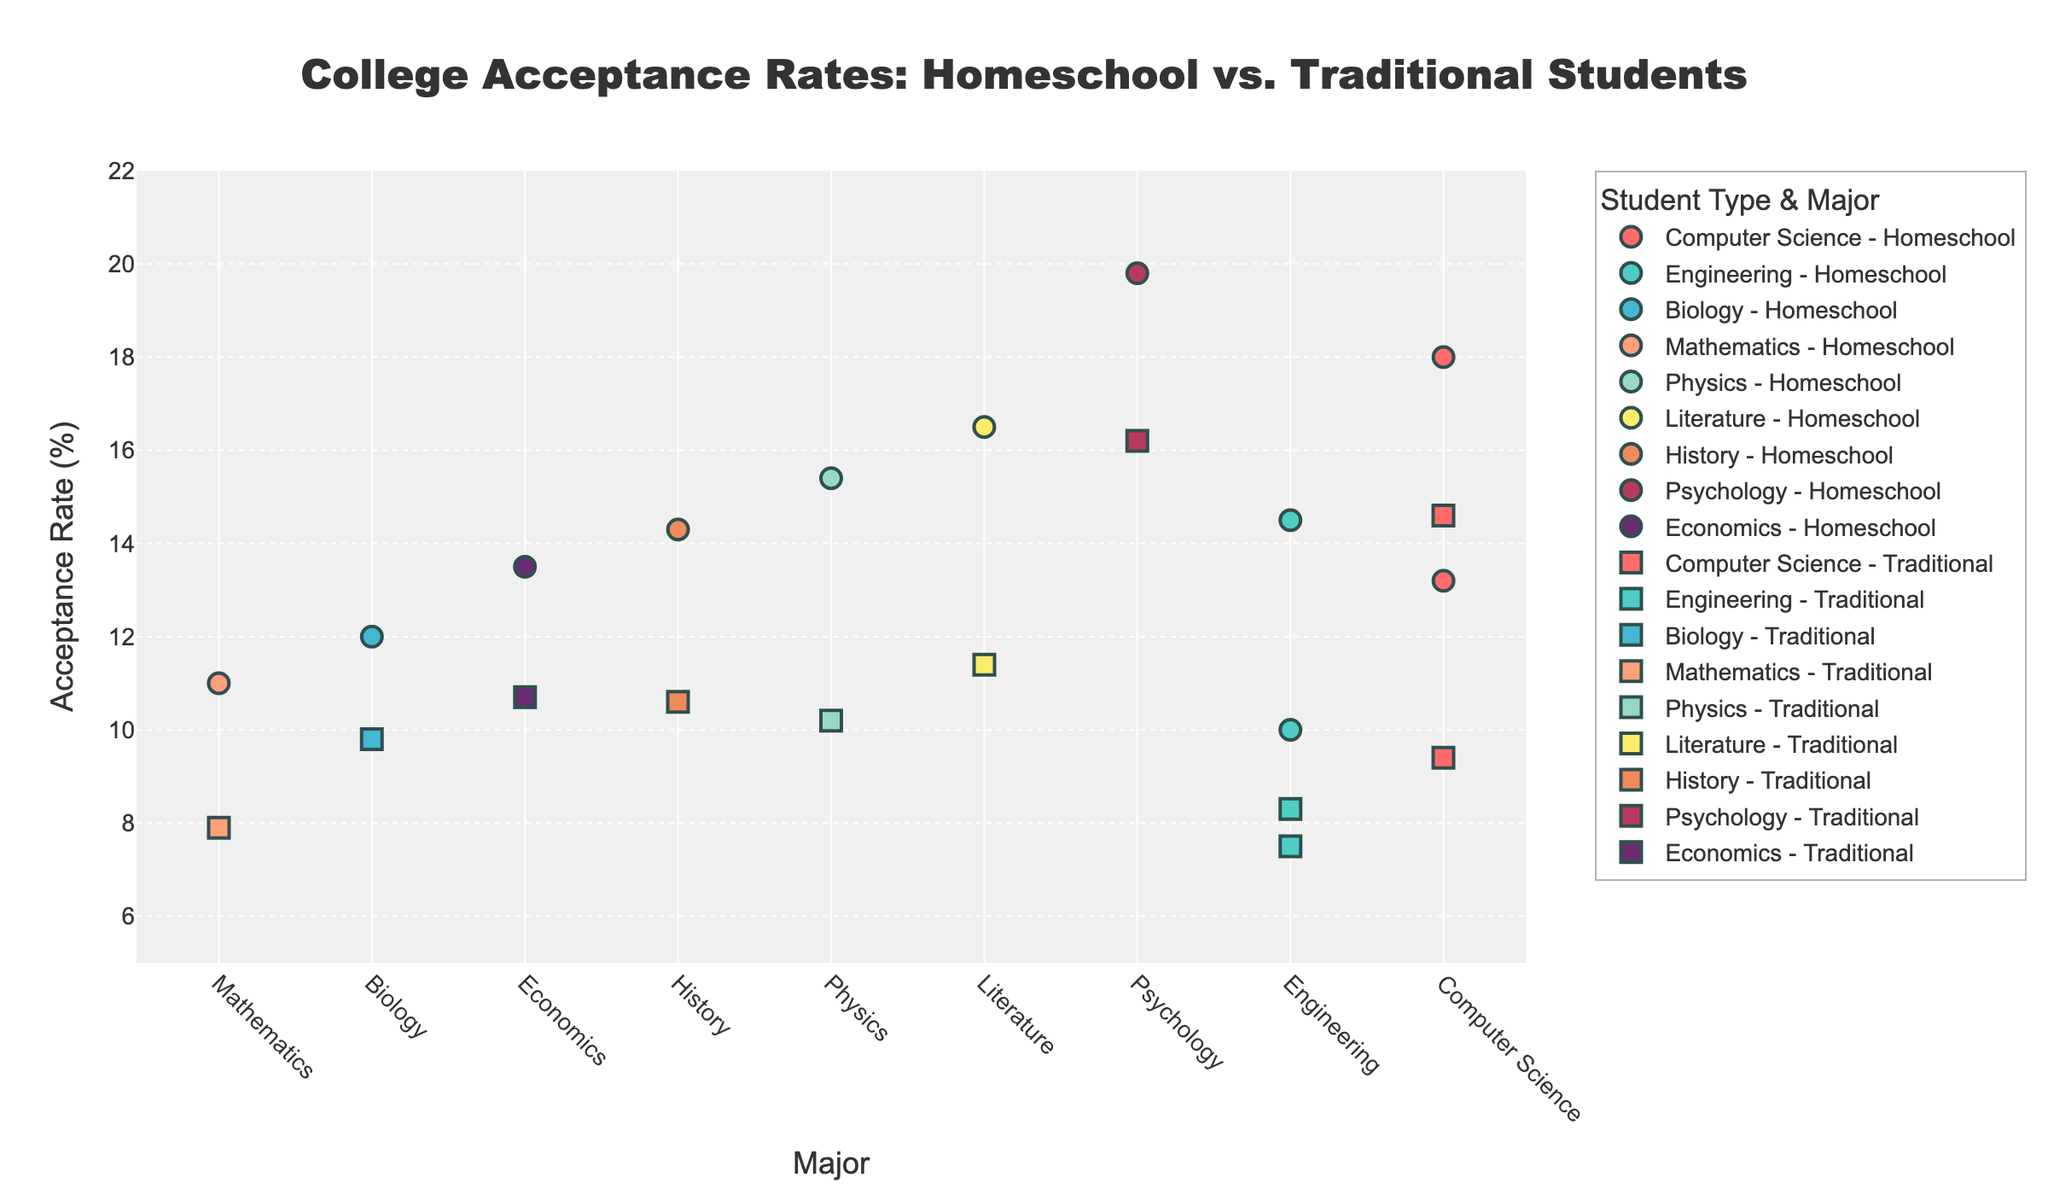What's the title of the plot? Look at the top of the figure where the title is located.
Answer: College Acceptance Rates: Homeschool vs. Traditional Students What does the x-axis represent? Look below the scatter plot where the x-axis label is located.
Answer: Major Which college has the highest acceptance rate for homeschooled students in Literature? Hover over the data points until you find the one for Literature with the highest acceptance rate for homeschooled students.
Answer: Yale What is the acceptance rate difference for Computer Science students between Stanford and UC Berkeley for homeschooled students? Find the acceptance rates for Computer Science at Stanford and UC Berkeley for homeschooled students and subtract them. Stanford: 13.2%, UC Berkeley: 18.0%. 18.0% - 13.2% = 4.8%
Answer: 4.8% Which major has the lowest acceptance rate for traditional students? Identify which data point for traditional students has the lowest acceptance rate by scanning the y-axis and the scatter plot. The lowest acceptance rate is in Engineering at MIT, which is 8.3%.
Answer: Engineering at MIT How many different majors are compared in this plot? Count the number of unique labels on the x-axis.
Answer: 9 What is the average acceptance rate for homeschooled students in Engineering? Find the acceptance rates for homeschooled students in Engineering. MIT: 14.5%, Caltech: 10.0%. Compute the average: (14.5% + 10.0%) / 2 = 12.25%.
Answer: 12.25% Which student type has higher acceptance rates overall, homeschool or traditional? Compare the overall pattern of the data points for both homeschooled and traditional students. Generally, homeschooled students have higher acceptance rates across most majors.
Answer: Homeschool What is the acceptance rate difference for Psychology students at UCLA between homeschool and traditional students? Find the acceptance rates for Psychology at UCLA. Homeschool: 19.8%, Traditional: 16.2%. Calculate the difference: 19.8% - 16.2% = 3.6%.
Answer: 3.6% For which major do traditional students have a higher acceptance rate than homeschool students at any college? Scan the data points for any major where the acceptance rate for traditional students is higher than that for homeschooled students. There are no instances of this in the given data.
Answer: None 